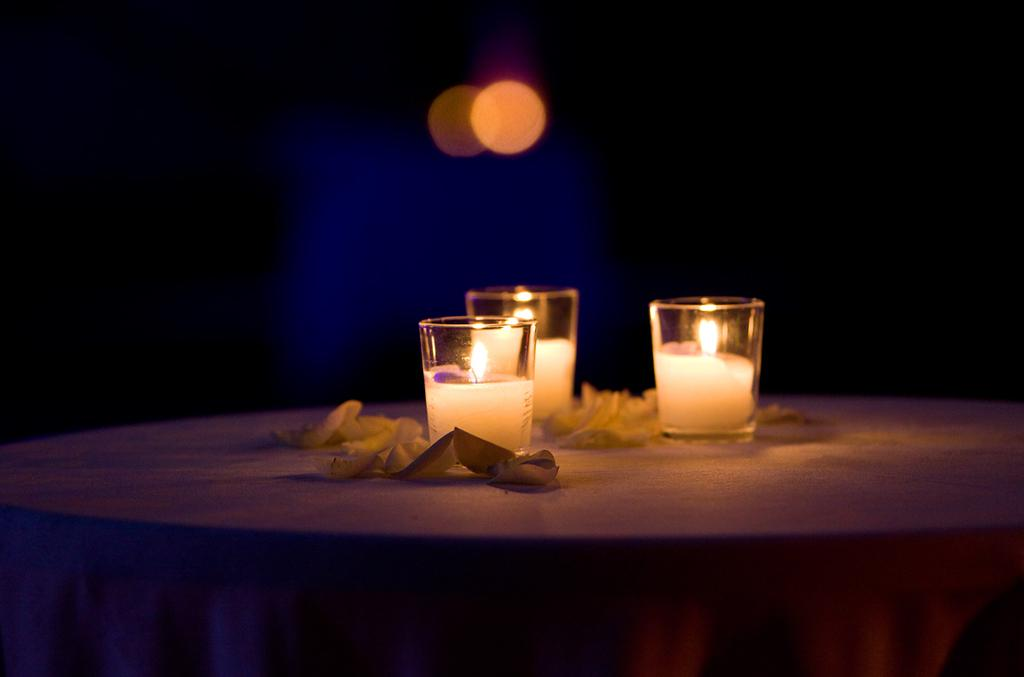What piece of furniture is present in the image? There is a table in the image. What is on the table? There are three glasses with a drink in them on the table. What else can be seen in the image besides the table and glasses? There is a cloth in the image. What nation is represented by the flag on the table in the image? There is no flag present on the table in the image. 